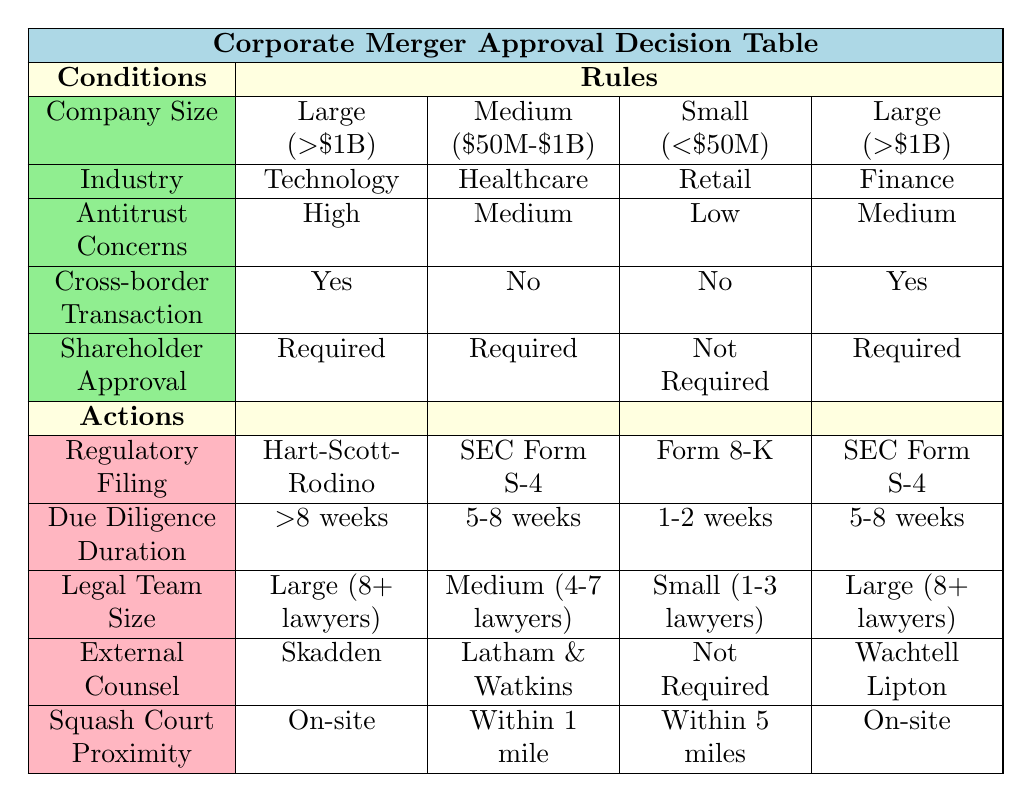What is the regulatory filing type for a large technology company with high antitrust concerns, a cross-border transaction, and requires shareholder approval? The table indicates that for a large company in the technology industry with high antitrust concerns, a cross-border transaction, and requiring shareholder approval, the regulatory filing required is "Hart-Scott-Rodino".
Answer: Hart-Scott-Rodino How long does due diligence take for a medium-sized healthcare company with medium antitrust concerns that does not require shareholder approval? According to the table, a medium-sized healthcare company with medium antitrust concerns that does not require shareholder approval will take "5-8 weeks" for due diligence.
Answer: 5-8 weeks Is external counsel required for small retail companies with low antitrust concerns that do not require shareholder approval? Yes, the table shows that for small retail companies with low antitrust concerns and not requiring shareholder approval, external counsel is "Not Required".
Answer: Yes What is the average legal team size for companies in the finance industry that are large and have medium antitrust concerns? There are two entries for large finance companies with medium antitrust concerns. Both have a legal team size of "Large (8+ lawyers)". Therefore, the average legal team size is "Large (8+ lawyers)", as both instances represent the same size.
Answer: Large (8+ lawyers) Which regulatory filing types are required for large companies in both the technology and finance industries? For large technology companies with high antitrust concerns and requiring shareholder approval, the regulatory filing is "Hart-Scott-Rodino". For large finance companies with medium antitrust concerns, the regulatory filing type is "SEC Form S-4". Therefore, the filing types required for large companies in these industries are "Hart-Scott-Rodino" and "SEC Form S-4".
Answer: Hart-Scott-Rodino and SEC Form S-4 How many companies in the table require on-site squash court proximity for their legal teams? Two entries in the table specify that on-site squash court proximity is required: one for a large technology company with high antitrust concerns and another for a large finance company with medium antitrust concerns. Therefore, the count is two.
Answer: 2 What is the difference in due diligence duration for small retail companies with low antitrust concerns compared to large technology companies with high antitrust concerns? The due diligence duration for small retail companies is "1-2 weeks", while for large technology companies, it is ">8 weeks". The difference is greater than 6 weeks (from 1 week to 8 weeks).
Answer: >6 weeks True or False: Medium-sized companies in the healthcare industry do not require external counsel if they have medium antitrust concerns and are cross-border transactions. According to the table, for medium-sized healthcare companies with medium antitrust concerns and not being cross-border transactions, external counsel is "Latham & Watkins" which means external counsel is required. Therefore, the statement is false.
Answer: False 